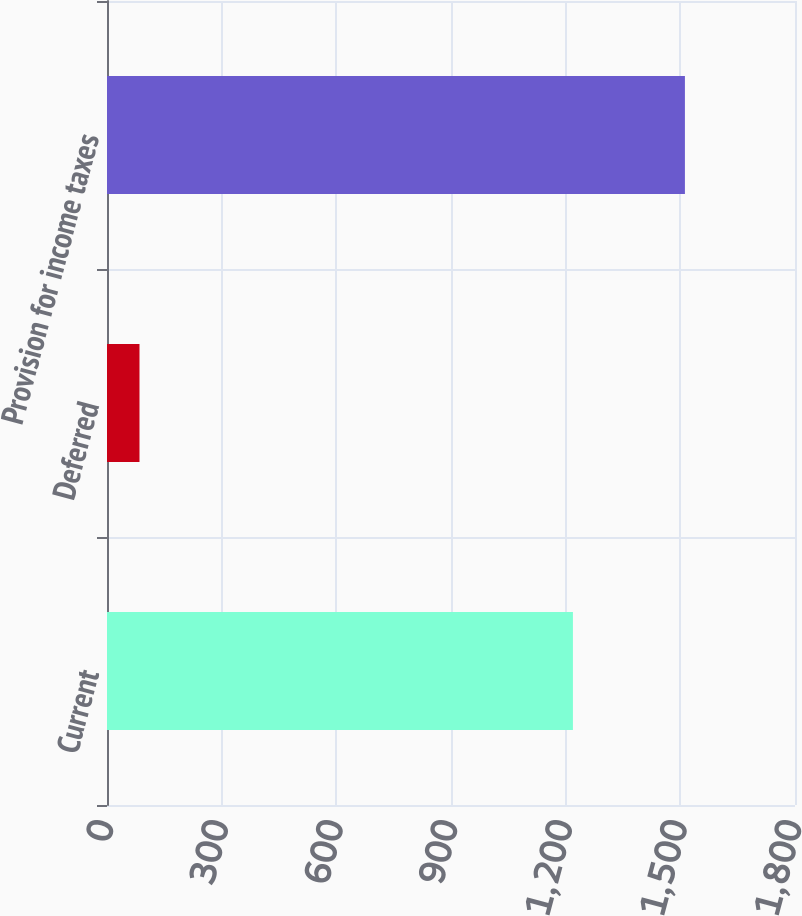Convert chart. <chart><loc_0><loc_0><loc_500><loc_500><bar_chart><fcel>Current<fcel>Deferred<fcel>Provision for income taxes<nl><fcel>1219<fcel>85<fcel>1512<nl></chart> 